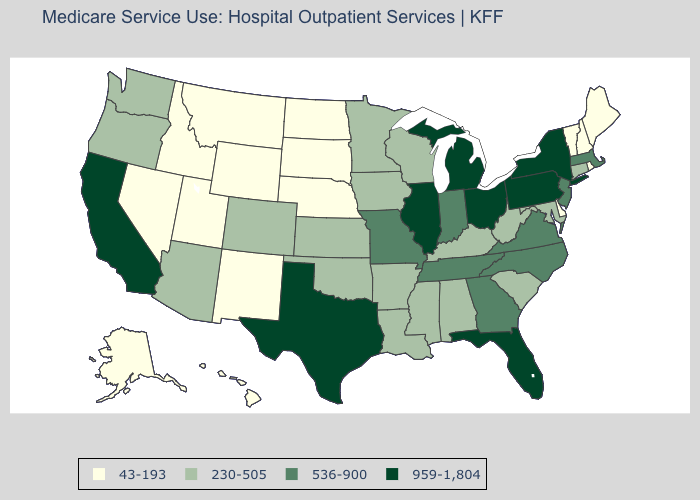Name the states that have a value in the range 959-1,804?
Keep it brief. California, Florida, Illinois, Michigan, New York, Ohio, Pennsylvania, Texas. Which states have the highest value in the USA?
Quick response, please. California, Florida, Illinois, Michigan, New York, Ohio, Pennsylvania, Texas. Name the states that have a value in the range 230-505?
Write a very short answer. Alabama, Arizona, Arkansas, Colorado, Connecticut, Iowa, Kansas, Kentucky, Louisiana, Maryland, Minnesota, Mississippi, Oklahoma, Oregon, South Carolina, Washington, West Virginia, Wisconsin. Name the states that have a value in the range 959-1,804?
Short answer required. California, Florida, Illinois, Michigan, New York, Ohio, Pennsylvania, Texas. Name the states that have a value in the range 959-1,804?
Keep it brief. California, Florida, Illinois, Michigan, New York, Ohio, Pennsylvania, Texas. Does Virginia have the highest value in the USA?
Quick response, please. No. Name the states that have a value in the range 230-505?
Write a very short answer. Alabama, Arizona, Arkansas, Colorado, Connecticut, Iowa, Kansas, Kentucky, Louisiana, Maryland, Minnesota, Mississippi, Oklahoma, Oregon, South Carolina, Washington, West Virginia, Wisconsin. Among the states that border Colorado , which have the lowest value?
Answer briefly. Nebraska, New Mexico, Utah, Wyoming. Name the states that have a value in the range 230-505?
Short answer required. Alabama, Arizona, Arkansas, Colorado, Connecticut, Iowa, Kansas, Kentucky, Louisiana, Maryland, Minnesota, Mississippi, Oklahoma, Oregon, South Carolina, Washington, West Virginia, Wisconsin. What is the value of Michigan?
Give a very brief answer. 959-1,804. Name the states that have a value in the range 230-505?
Answer briefly. Alabama, Arizona, Arkansas, Colorado, Connecticut, Iowa, Kansas, Kentucky, Louisiana, Maryland, Minnesota, Mississippi, Oklahoma, Oregon, South Carolina, Washington, West Virginia, Wisconsin. Does the map have missing data?
Concise answer only. No. Which states hav the highest value in the MidWest?
Quick response, please. Illinois, Michigan, Ohio. What is the value of Missouri?
Be succinct. 536-900. Does the map have missing data?
Concise answer only. No. 